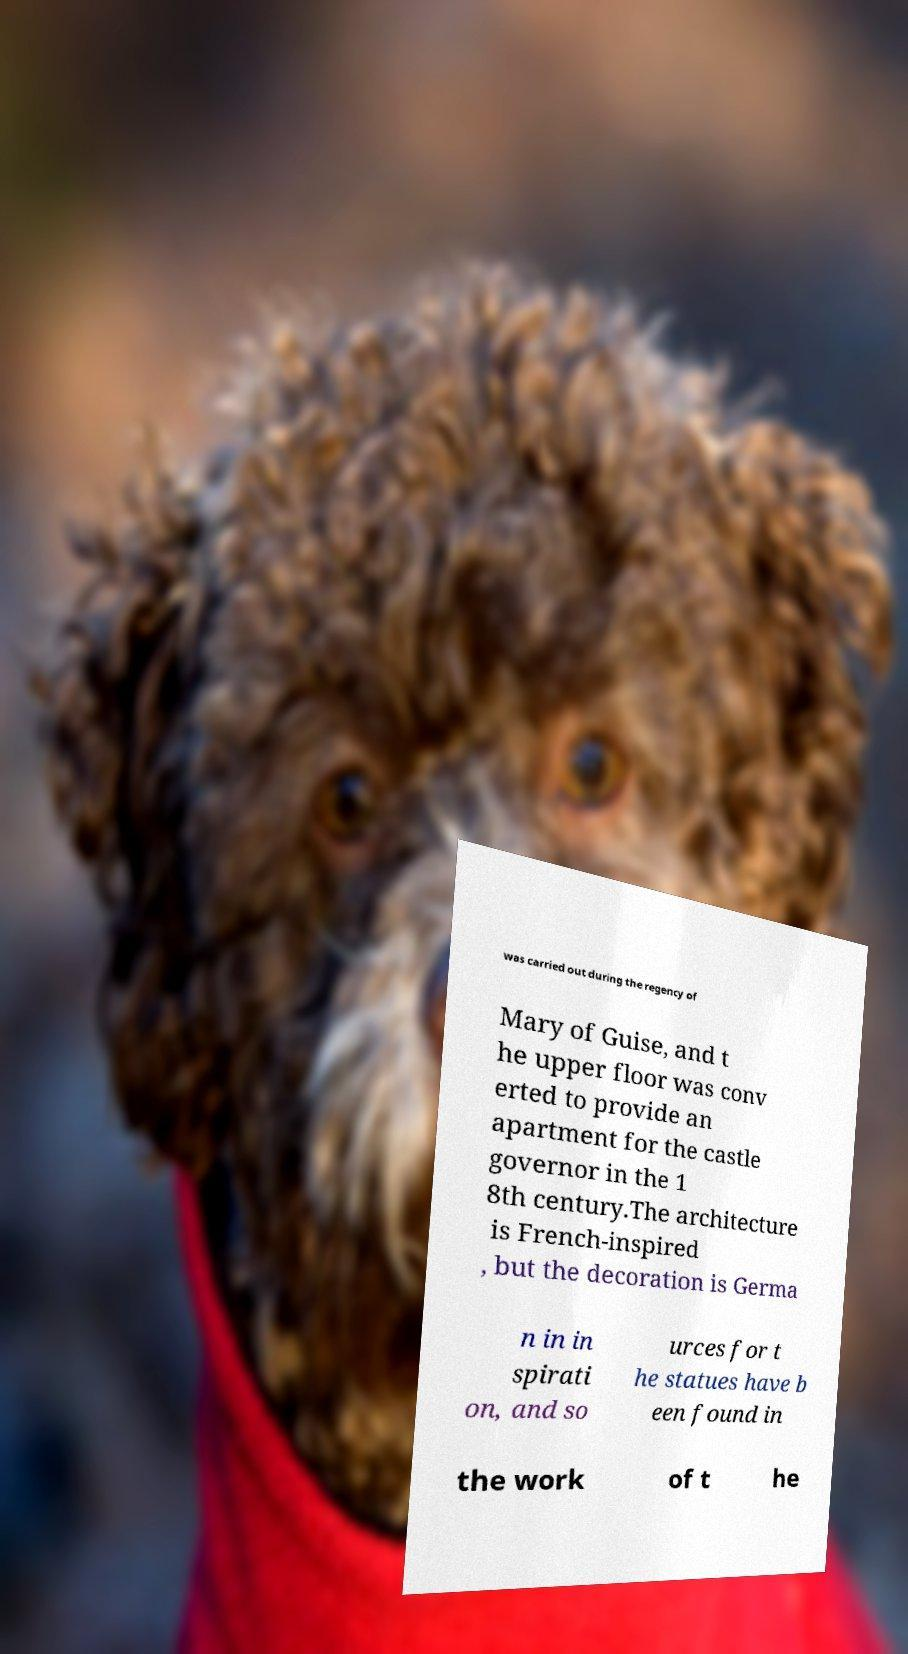For documentation purposes, I need the text within this image transcribed. Could you provide that? was carried out during the regency of Mary of Guise, and t he upper floor was conv erted to provide an apartment for the castle governor in the 1 8th century.The architecture is French-inspired , but the decoration is Germa n in in spirati on, and so urces for t he statues have b een found in the work of t he 